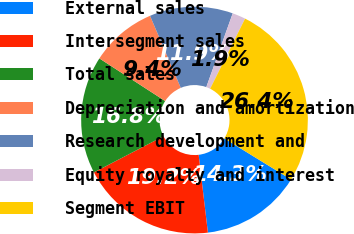<chart> <loc_0><loc_0><loc_500><loc_500><pie_chart><fcel>External sales<fcel>Intersegment sales<fcel>Total sales<fcel>Depreciation and amortization<fcel>Research development and<fcel>Equity royalty and interest<fcel>Segment EBIT<nl><fcel>14.34%<fcel>19.25%<fcel>16.79%<fcel>9.43%<fcel>11.89%<fcel>1.89%<fcel>26.42%<nl></chart> 